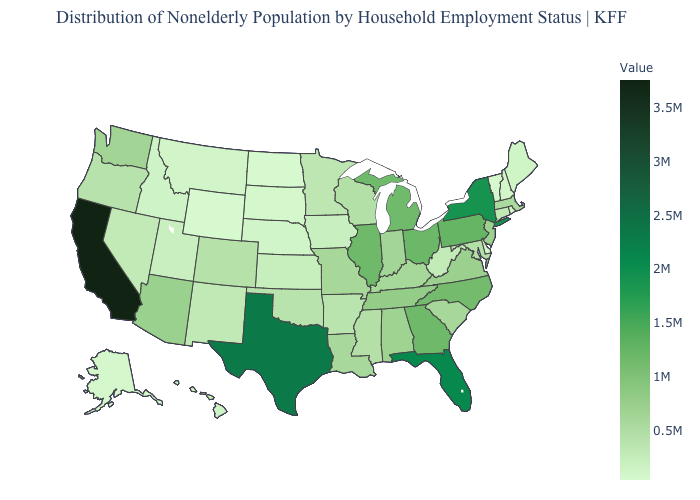Among the states that border North Carolina , which have the lowest value?
Short answer required. South Carolina. Does Wyoming have the lowest value in the USA?
Be succinct. Yes. Among the states that border Alabama , which have the highest value?
Give a very brief answer. Florida. 